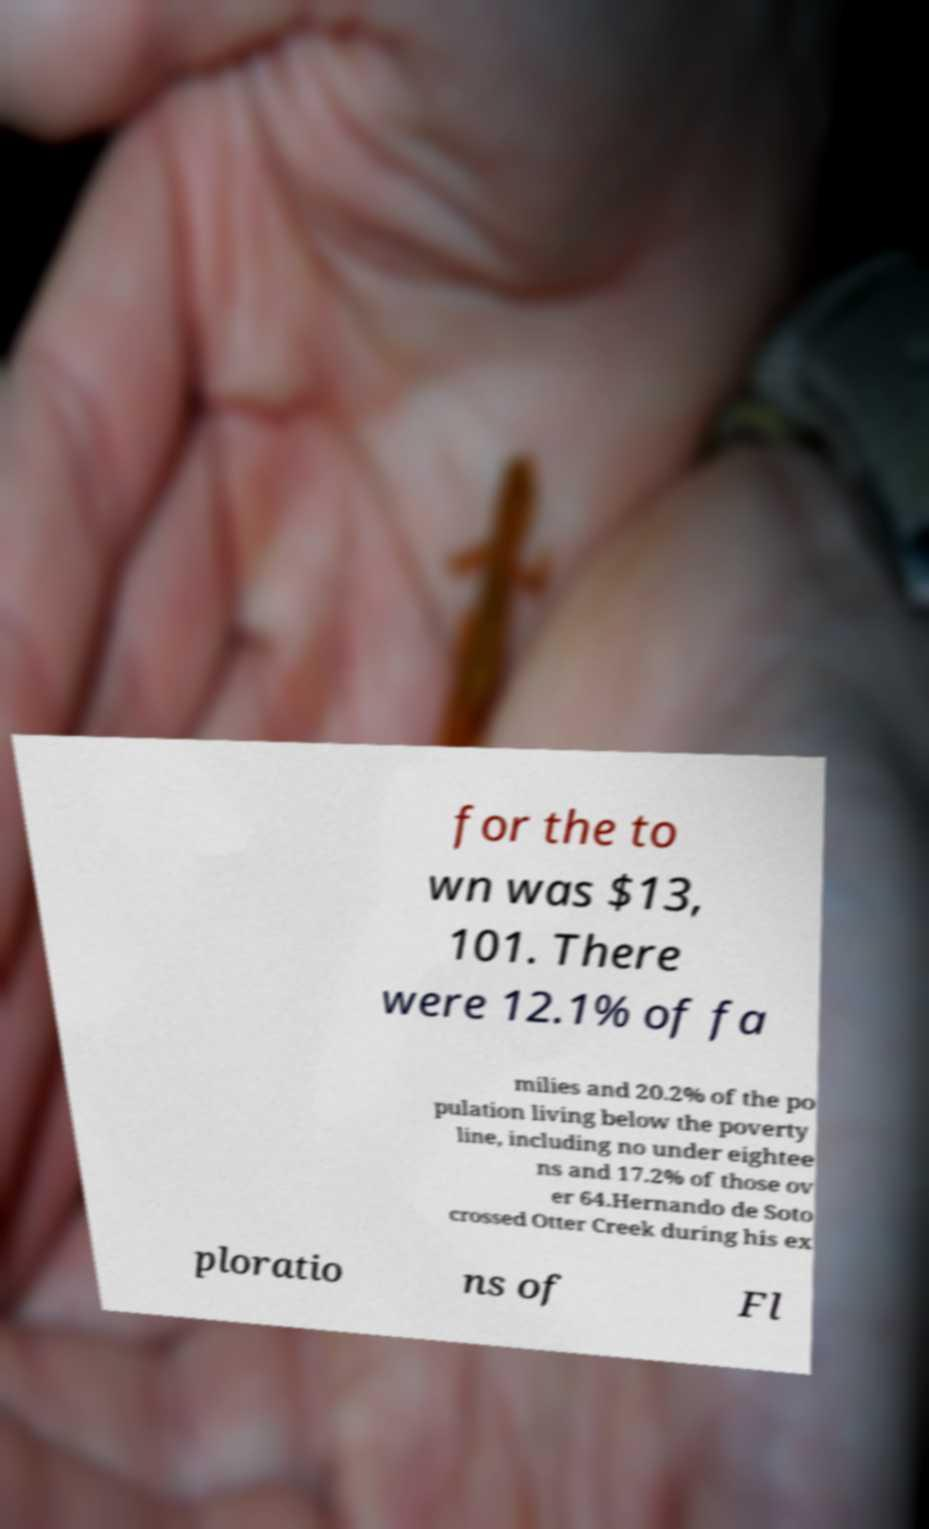For documentation purposes, I need the text within this image transcribed. Could you provide that? for the to wn was $13, 101. There were 12.1% of fa milies and 20.2% of the po pulation living below the poverty line, including no under eightee ns and 17.2% of those ov er 64.Hernando de Soto crossed Otter Creek during his ex ploratio ns of Fl 